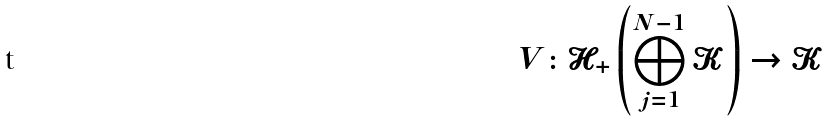Convert formula to latex. <formula><loc_0><loc_0><loc_500><loc_500>V \colon \mathcal { H } _ { + } \left ( \bigoplus _ { j = 1 } ^ { N - 1 } \mathcal { K } \right ) \rightarrow \mathcal { K }</formula> 